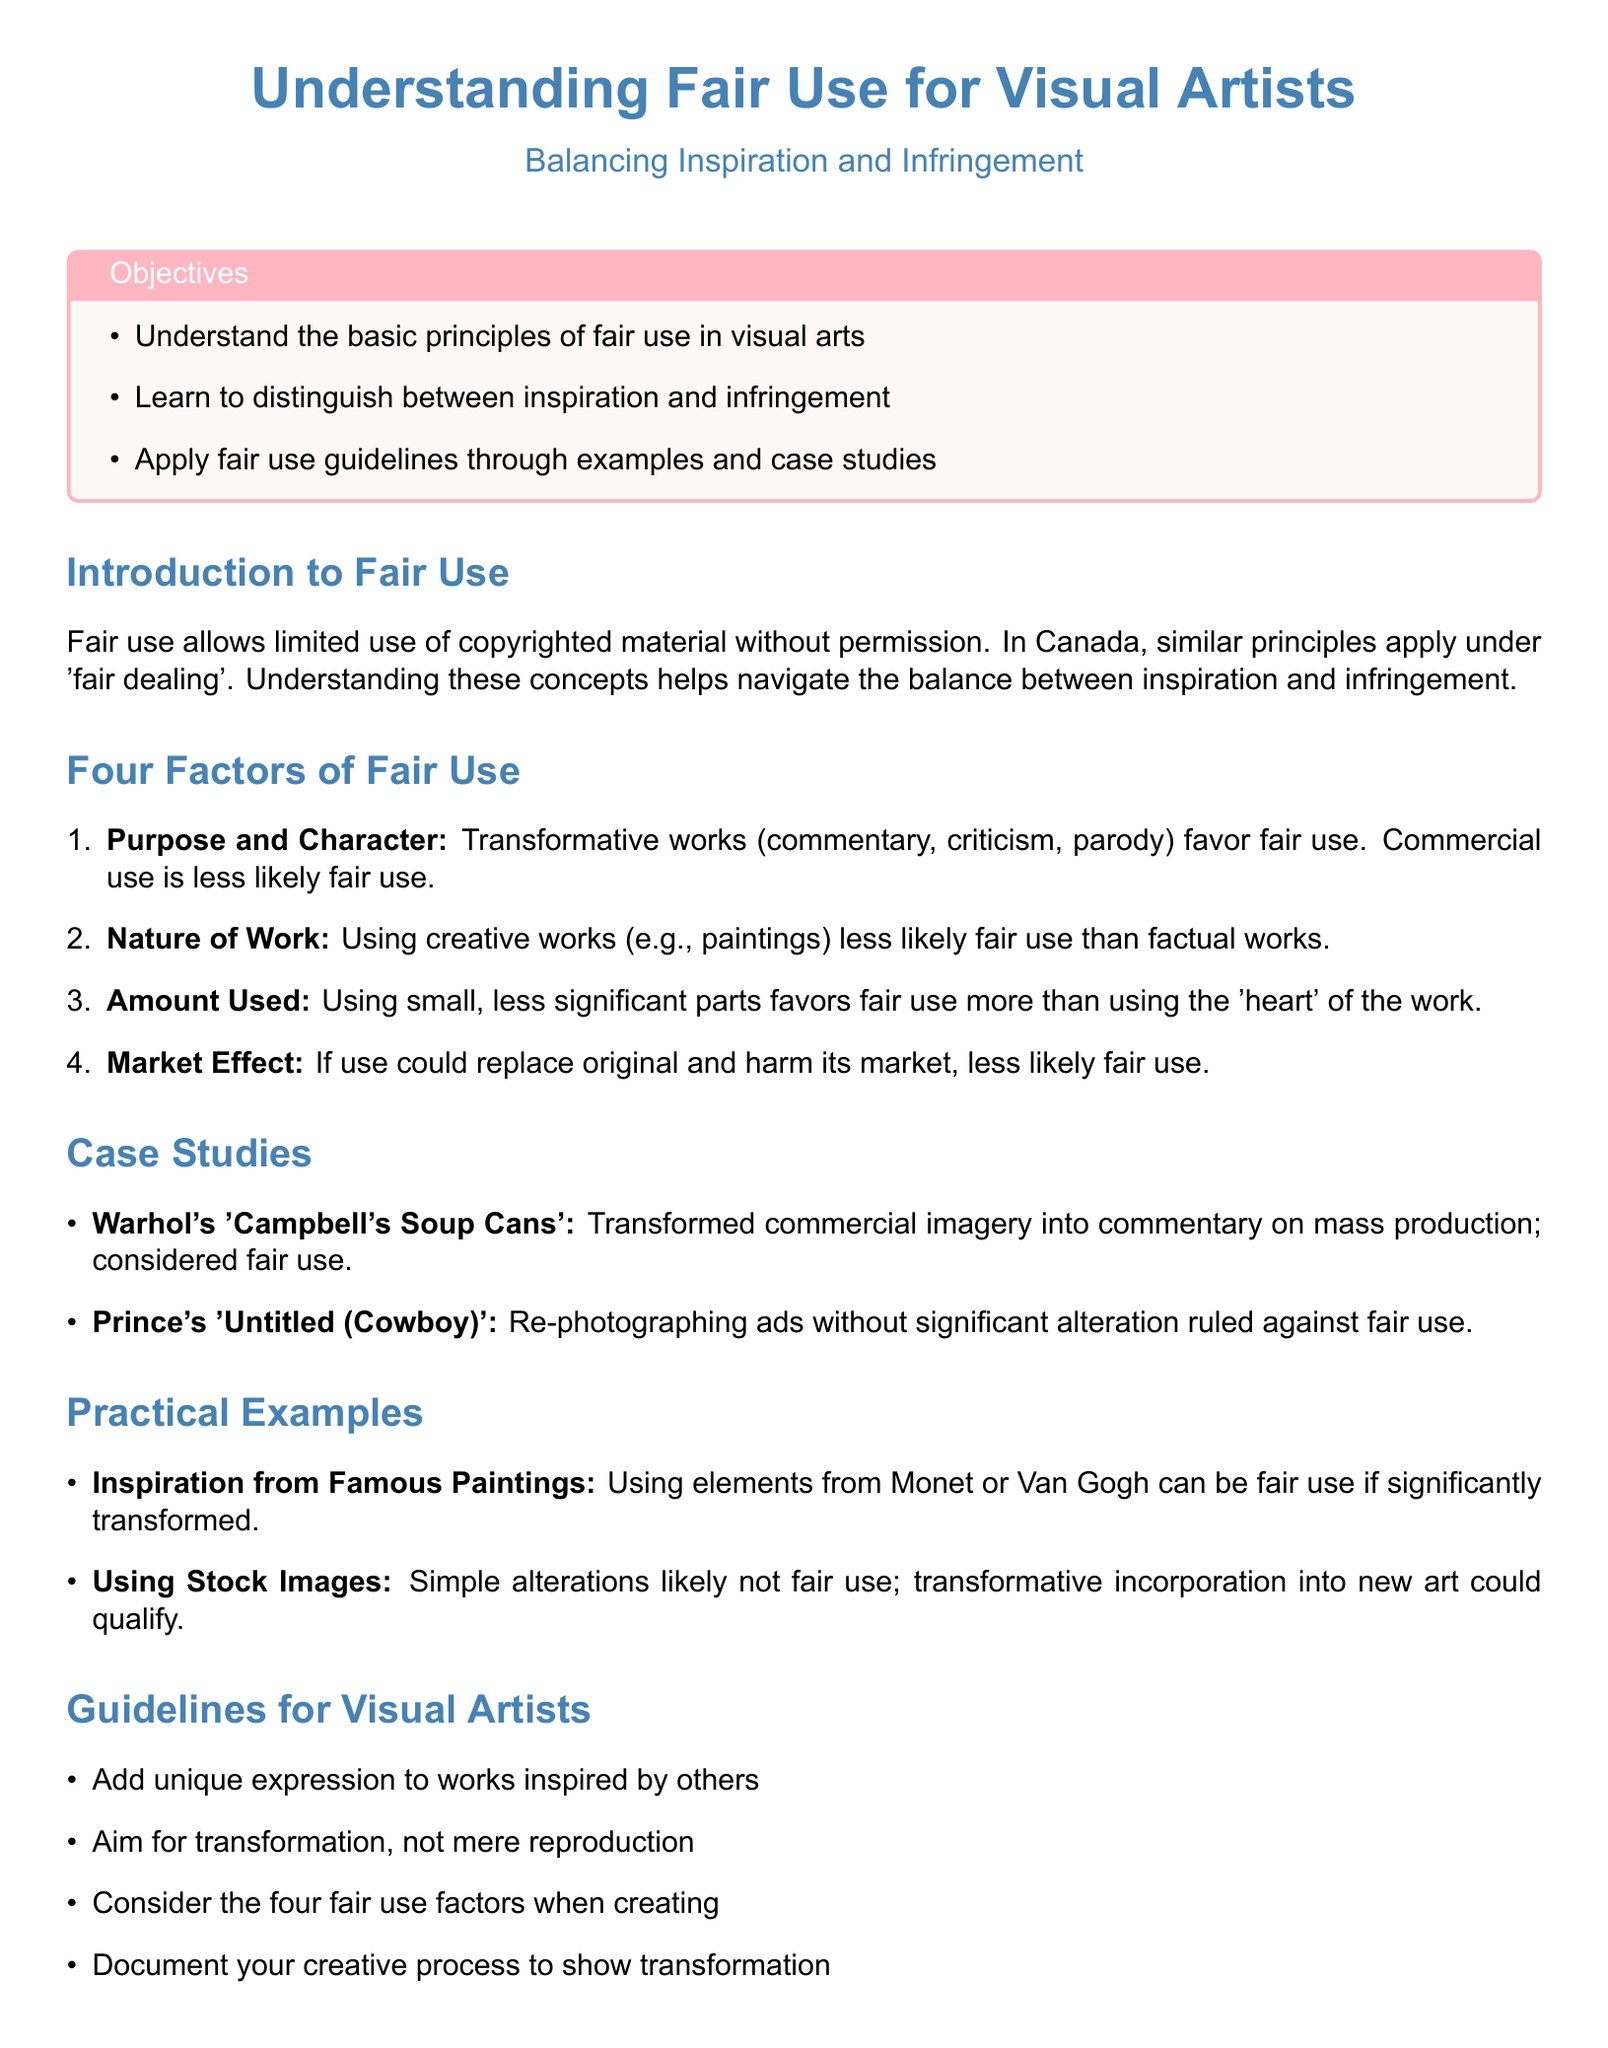What is the title of the lesson plan? The title of the lesson plan is presented prominently at the beginning of the document.
Answer: Understanding Fair Use for Visual Artists What is the main objective of the lesson plan? The main objective is stated in the objectives box, summarizing what learners will achieve.
Answer: Understand the basic principles of fair use in visual arts What are the four factors of fair use? The four factors of fair use are outlined in a numbered list in the document.
Answer: Purpose and Character, Nature of Work, Amount Used, Market Effect Which case study involved Warhol? The case study related to Warhol is mentioned to illustrate fair use.
Answer: Warhol's 'Campbell's Soup Cans' What is a key guideline for visual artists? A key guideline is listed under the guidelines section, helping artists navigate fair use.
Answer: Add unique expression to works inspired by others What type of use is less likely to be fair use? The lesson plan describes certain types of works and uses that are less likely to qualify for fair use.
Answer: Creative works What does transformative use favor in the fair use assessment? The document explains transformative use as part of the criteria for determining fair use.
Answer: Fair use What does the case study involving Prince illustrate? The Prince case study is used to demonstrate a situation that did not qualify as fair use.
Answer: Re-photographing ads without significant alteration ruled against fair use How can visual artists document their creative process? The document provides a guideline that suggests a way to demonstrate compliance with fair use principles.
Answer: Document your creative process to show transformation 